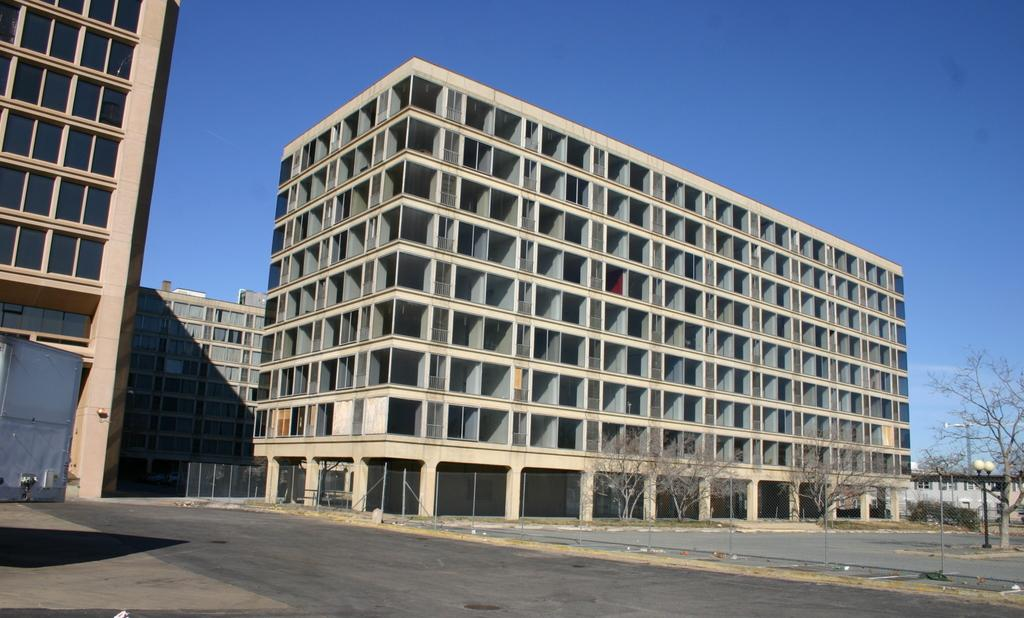What is located at the bottom of the image? There is a road and a fence at the bottom of the image. What can be seen in the background of the image? There are buildings, bare trees, light poles, and a crane in the background of the image. What part of the natural environment is visible in the image? The sky is visible in the background of the image. Can you tell me how many berries are on the crane in the image? There are no berries present in the image; the crane is a construction vehicle. Is there a plane flying in the sky in the image? There is no plane visible in the sky in the image. 